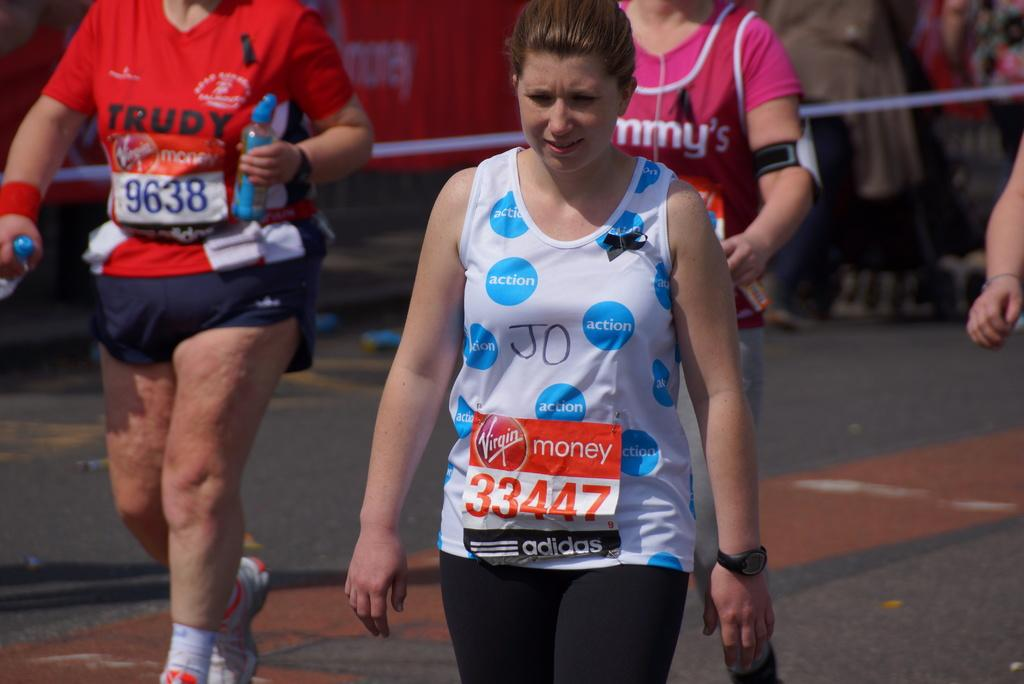<image>
Present a compact description of the photo's key features. Various people in a marathon with the woman in front named Jo. 